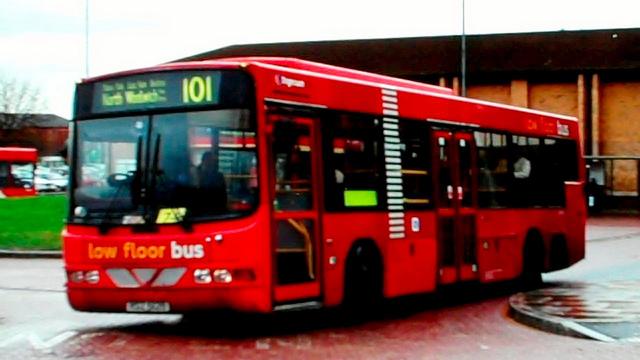Is this bus somewhere other than North America?
Write a very short answer. Yes. Is this a low floor bus?
Short answer required. Yes. What is the bus number?
Write a very short answer. 101. 